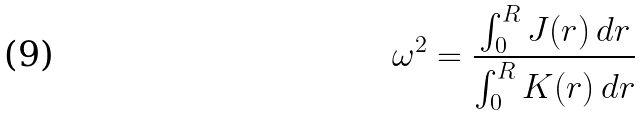<formula> <loc_0><loc_0><loc_500><loc_500>\omega ^ { 2 } = \frac { \int _ { 0 } ^ { R } J ( r ) \, d r } { \int _ { 0 } ^ { R } K ( r ) \, d r }</formula> 